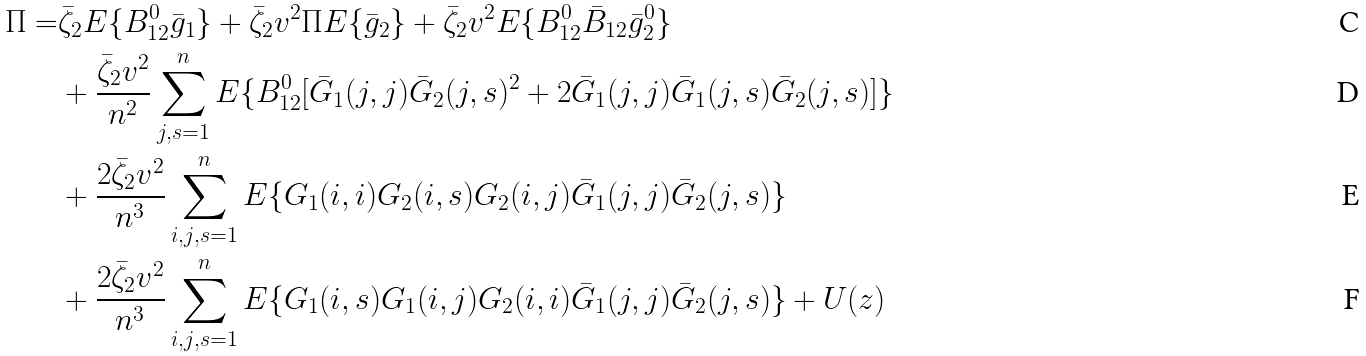Convert formula to latex. <formula><loc_0><loc_0><loc_500><loc_500>\Pi = & \bar { \zeta } _ { 2 } { E } \{ B _ { 1 2 } ^ { 0 } \bar { g } _ { 1 } \} + \bar { \zeta } _ { 2 } v ^ { 2 } \Pi { E } \{ \bar { g } _ { 2 } \} + \bar { \zeta } _ { 2 } v ^ { 2 } { E } \{ B _ { 1 2 } ^ { 0 } \bar { B } _ { 1 2 } \bar { g } _ { 2 } ^ { 0 } \} \\ & + \frac { \bar { \zeta } _ { 2 } v ^ { 2 } } { n ^ { 2 } } \sum _ { j , s = 1 } ^ { n } { E } \{ B _ { 1 2 } ^ { 0 } [ \bar { G } _ { 1 } ( j , j ) \bar { G } _ { 2 } ( j , s ) ^ { 2 } + 2 \bar { G } _ { 1 } ( j , j ) \bar { G } _ { 1 } ( j , s ) \bar { G } _ { 2 } ( j , s ) ] \} \\ & + \frac { 2 \bar { \zeta } _ { 2 } v ^ { 2 } } { n ^ { 3 } } \sum _ { i , j , s = 1 } ^ { n } { E } \{ G _ { 1 } ( i , i ) G _ { 2 } ( i , s ) G _ { 2 } ( i , j ) \bar { G } _ { 1 } ( j , j ) \bar { G } _ { 2 } ( j , s ) \} \\ & + \frac { 2 \bar { \zeta } _ { 2 } v ^ { 2 } } { n ^ { 3 } } \sum _ { i , j , s = 1 } ^ { n } { E } \{ G _ { 1 } ( i , s ) G _ { 1 } ( i , j ) G _ { 2 } ( i , i ) \bar { G } _ { 1 } ( j , j ) \bar { G } _ { 2 } ( j , s ) \} + U ( z )</formula> 